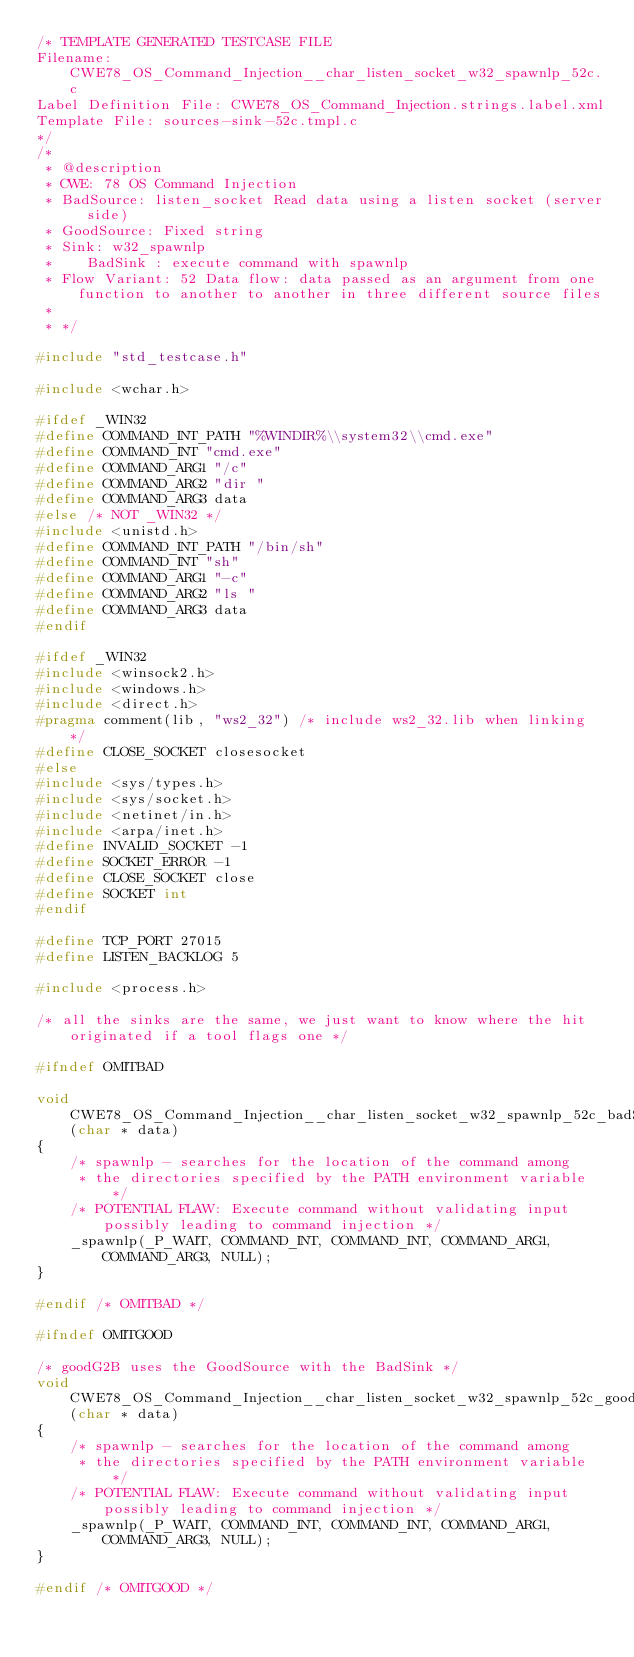Convert code to text. <code><loc_0><loc_0><loc_500><loc_500><_C_>/* TEMPLATE GENERATED TESTCASE FILE
Filename: CWE78_OS_Command_Injection__char_listen_socket_w32_spawnlp_52c.c
Label Definition File: CWE78_OS_Command_Injection.strings.label.xml
Template File: sources-sink-52c.tmpl.c
*/
/*
 * @description
 * CWE: 78 OS Command Injection
 * BadSource: listen_socket Read data using a listen socket (server side)
 * GoodSource: Fixed string
 * Sink: w32_spawnlp
 *    BadSink : execute command with spawnlp
 * Flow Variant: 52 Data flow: data passed as an argument from one function to another to another in three different source files
 *
 * */

#include "std_testcase.h"

#include <wchar.h>

#ifdef _WIN32
#define COMMAND_INT_PATH "%WINDIR%\\system32\\cmd.exe"
#define COMMAND_INT "cmd.exe"
#define COMMAND_ARG1 "/c"
#define COMMAND_ARG2 "dir "
#define COMMAND_ARG3 data
#else /* NOT _WIN32 */
#include <unistd.h>
#define COMMAND_INT_PATH "/bin/sh"
#define COMMAND_INT "sh"
#define COMMAND_ARG1 "-c"
#define COMMAND_ARG2 "ls "
#define COMMAND_ARG3 data
#endif

#ifdef _WIN32
#include <winsock2.h>
#include <windows.h>
#include <direct.h>
#pragma comment(lib, "ws2_32") /* include ws2_32.lib when linking */
#define CLOSE_SOCKET closesocket
#else
#include <sys/types.h>
#include <sys/socket.h>
#include <netinet/in.h>
#include <arpa/inet.h>
#define INVALID_SOCKET -1
#define SOCKET_ERROR -1
#define CLOSE_SOCKET close
#define SOCKET int
#endif

#define TCP_PORT 27015
#define LISTEN_BACKLOG 5

#include <process.h>

/* all the sinks are the same, we just want to know where the hit originated if a tool flags one */

#ifndef OMITBAD

void CWE78_OS_Command_Injection__char_listen_socket_w32_spawnlp_52c_badSink(char * data)
{
    /* spawnlp - searches for the location of the command among
     * the directories specified by the PATH environment variable */
    /* POTENTIAL FLAW: Execute command without validating input possibly leading to command injection */
    _spawnlp(_P_WAIT, COMMAND_INT, COMMAND_INT, COMMAND_ARG1, COMMAND_ARG3, NULL);
}

#endif /* OMITBAD */

#ifndef OMITGOOD

/* goodG2B uses the GoodSource with the BadSink */
void CWE78_OS_Command_Injection__char_listen_socket_w32_spawnlp_52c_goodG2BSink(char * data)
{
    /* spawnlp - searches for the location of the command among
     * the directories specified by the PATH environment variable */
    /* POTENTIAL FLAW: Execute command without validating input possibly leading to command injection */
    _spawnlp(_P_WAIT, COMMAND_INT, COMMAND_INT, COMMAND_ARG1, COMMAND_ARG3, NULL);
}

#endif /* OMITGOOD */
</code> 